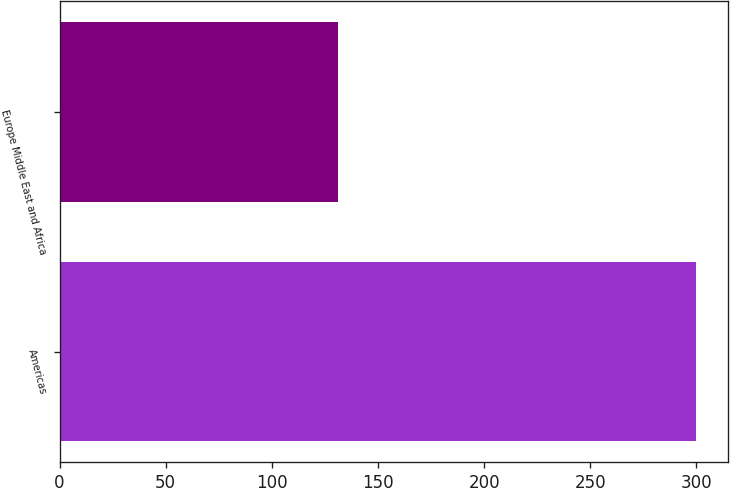Convert chart to OTSL. <chart><loc_0><loc_0><loc_500><loc_500><bar_chart><fcel>Americas<fcel>Europe Middle East and Africa<nl><fcel>300<fcel>131.1<nl></chart> 